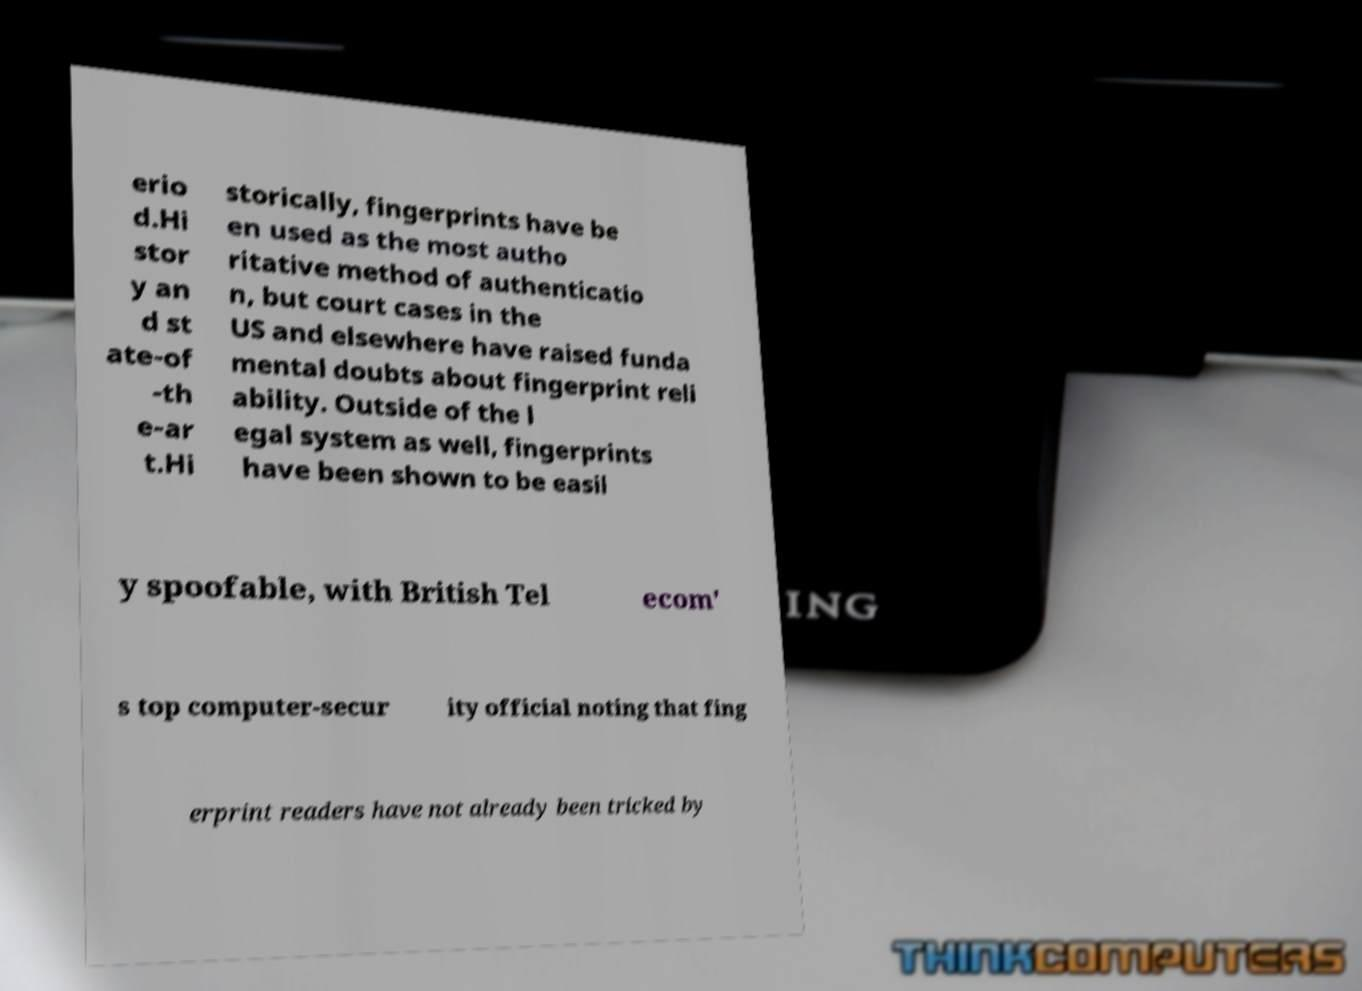Could you assist in decoding the text presented in this image and type it out clearly? erio d.Hi stor y an d st ate-of -th e-ar t.Hi storically, fingerprints have be en used as the most autho ritative method of authenticatio n, but court cases in the US and elsewhere have raised funda mental doubts about fingerprint reli ability. Outside of the l egal system as well, fingerprints have been shown to be easil y spoofable, with British Tel ecom' s top computer-secur ity official noting that fing erprint readers have not already been tricked by 